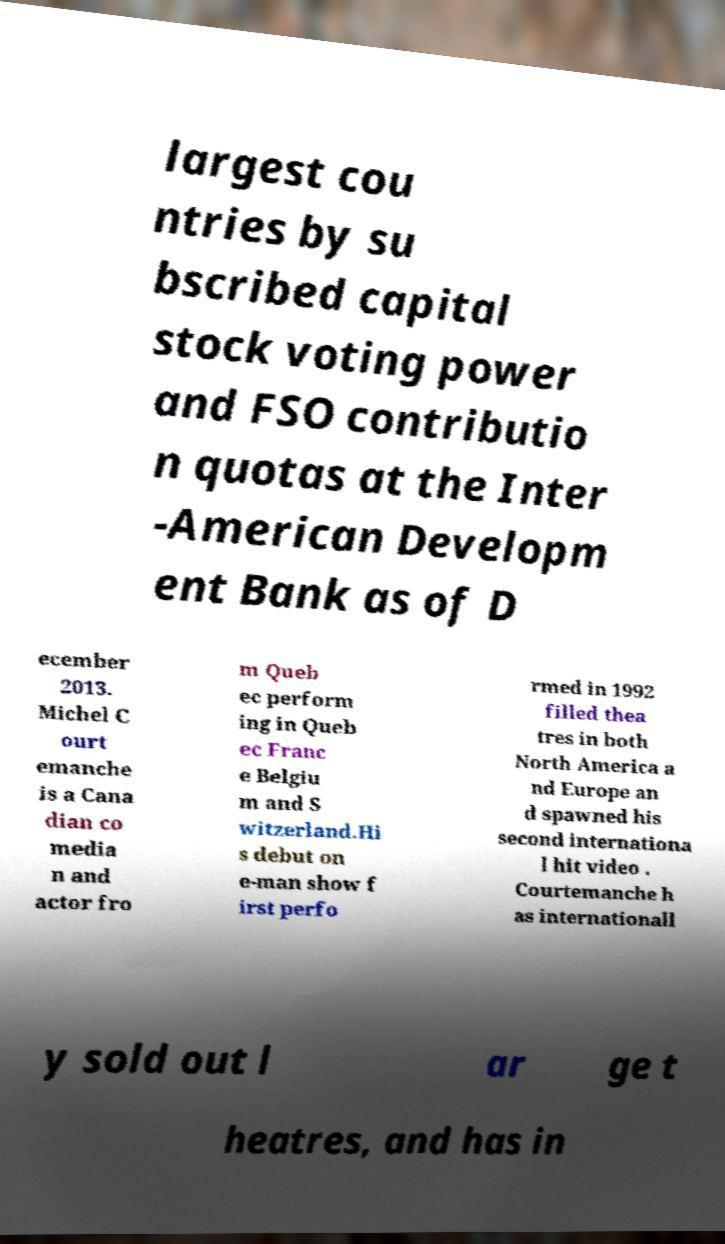For documentation purposes, I need the text within this image transcribed. Could you provide that? largest cou ntries by su bscribed capital stock voting power and FSO contributio n quotas at the Inter -American Developm ent Bank as of D ecember 2013. Michel C ourt emanche is a Cana dian co media n and actor fro m Queb ec perform ing in Queb ec Franc e Belgiu m and S witzerland.Hi s debut on e-man show f irst perfo rmed in 1992 filled thea tres in both North America a nd Europe an d spawned his second internationa l hit video . Courtemanche h as internationall y sold out l ar ge t heatres, and has in 